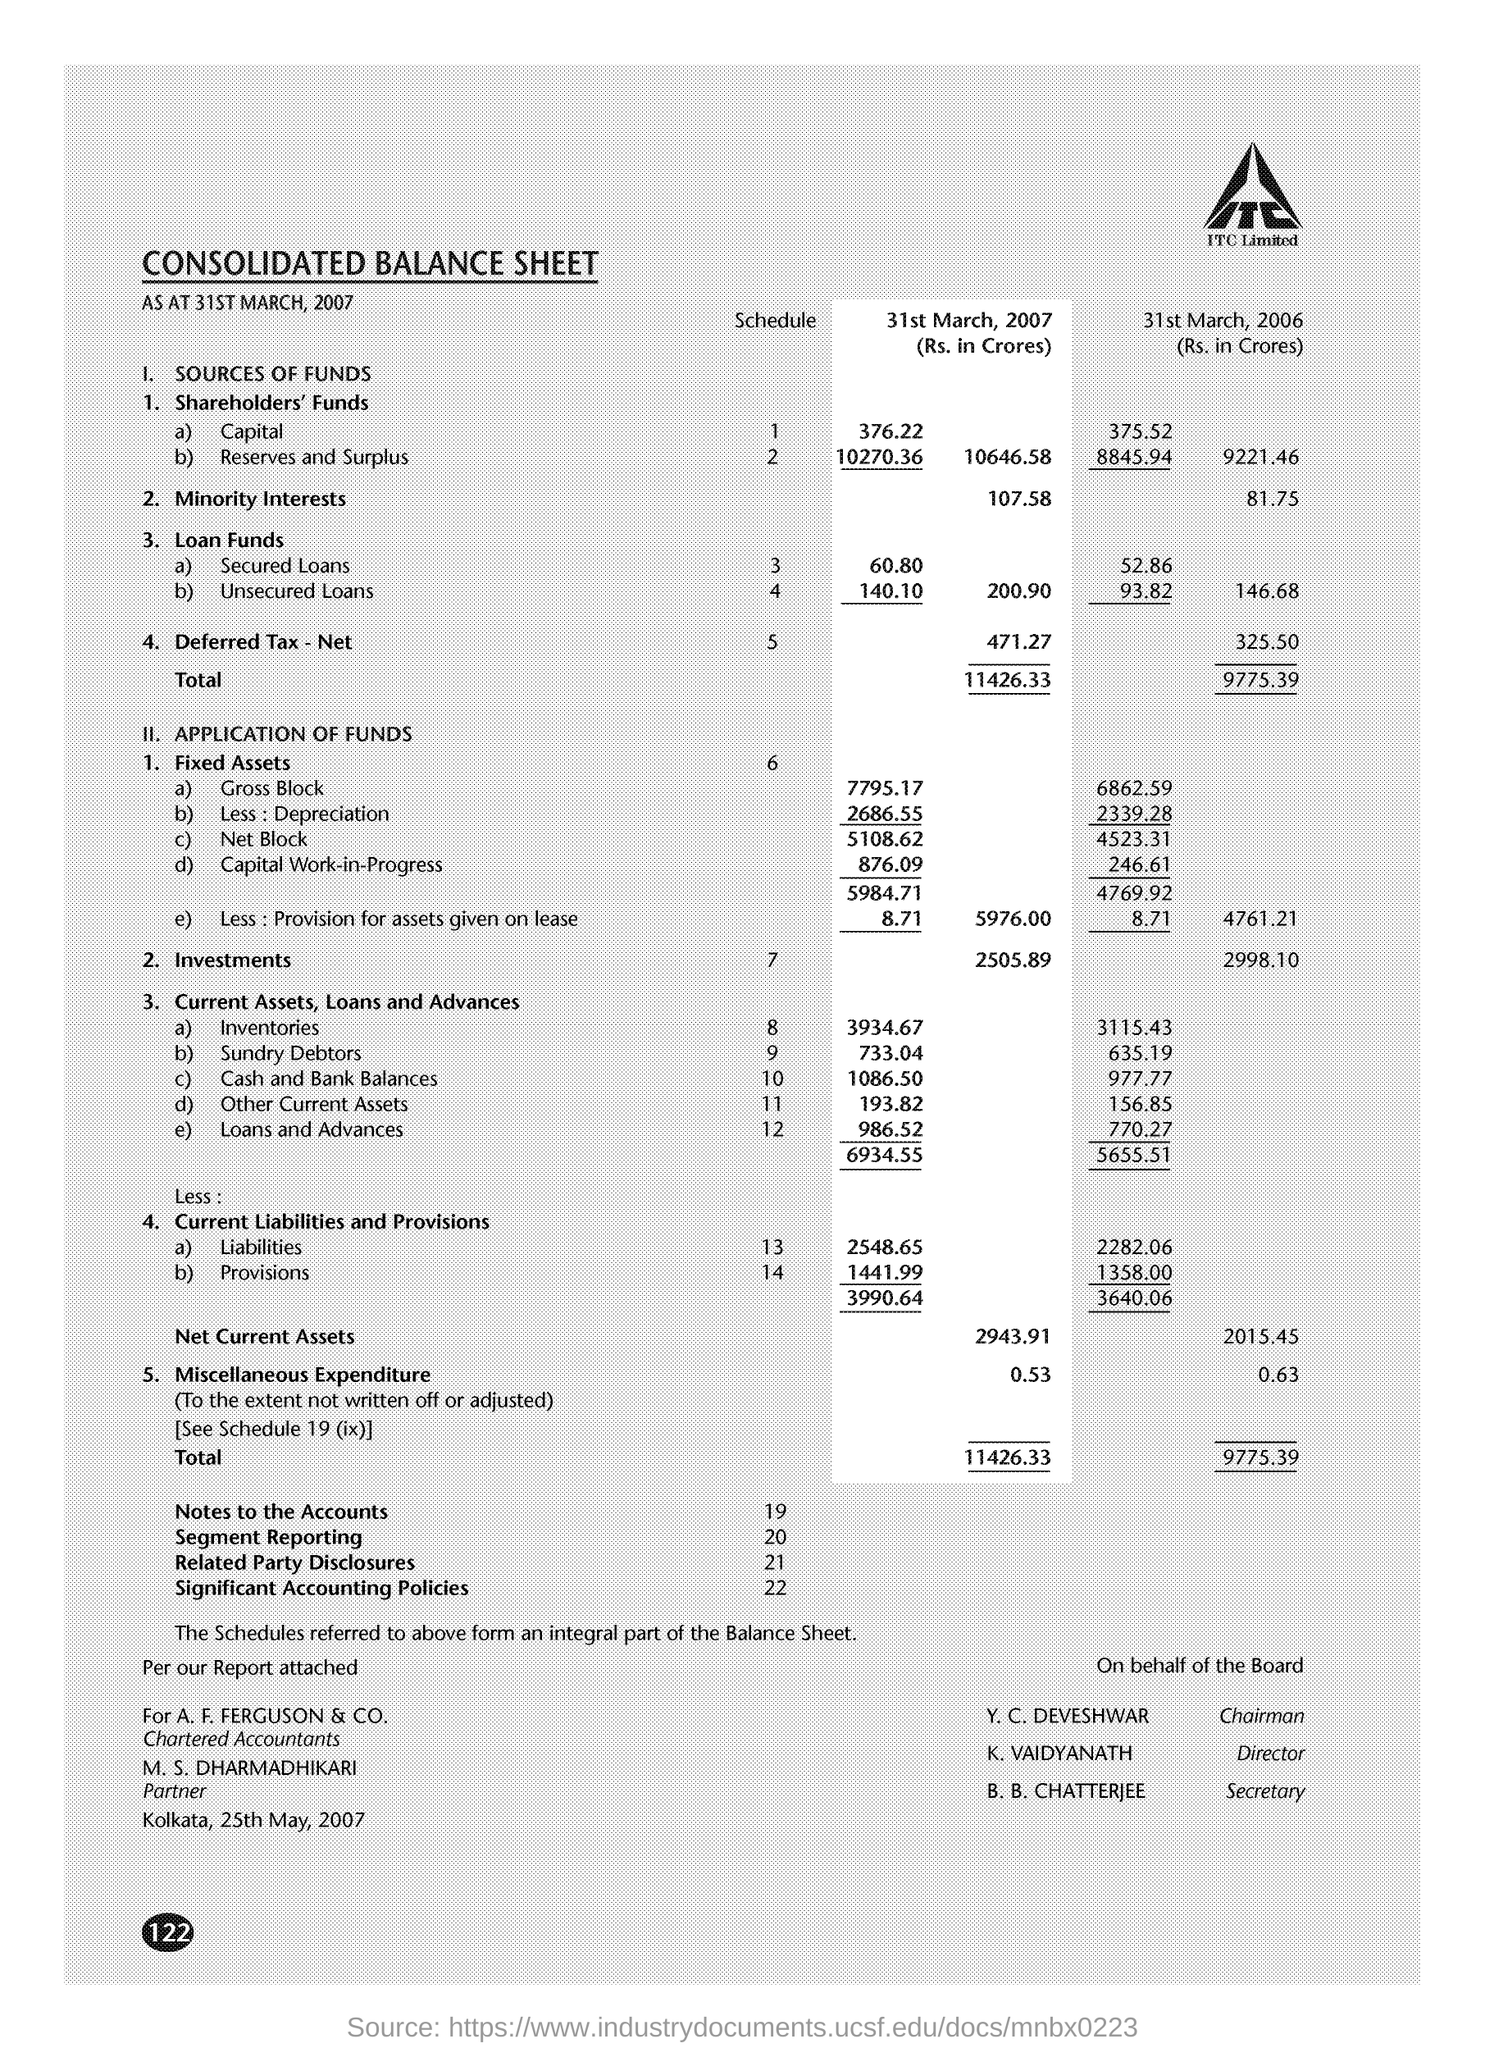Can you tell me the increase in 'Reserves and Surplus' from 31st March 2006 to 31st March 2007? The 'Reserves and Surplus' increased by ₹142.78 Crores, from ₹9845.94 Crores on 31st March 2006 to ₹10270.36 Crores on 31st March 2007. 